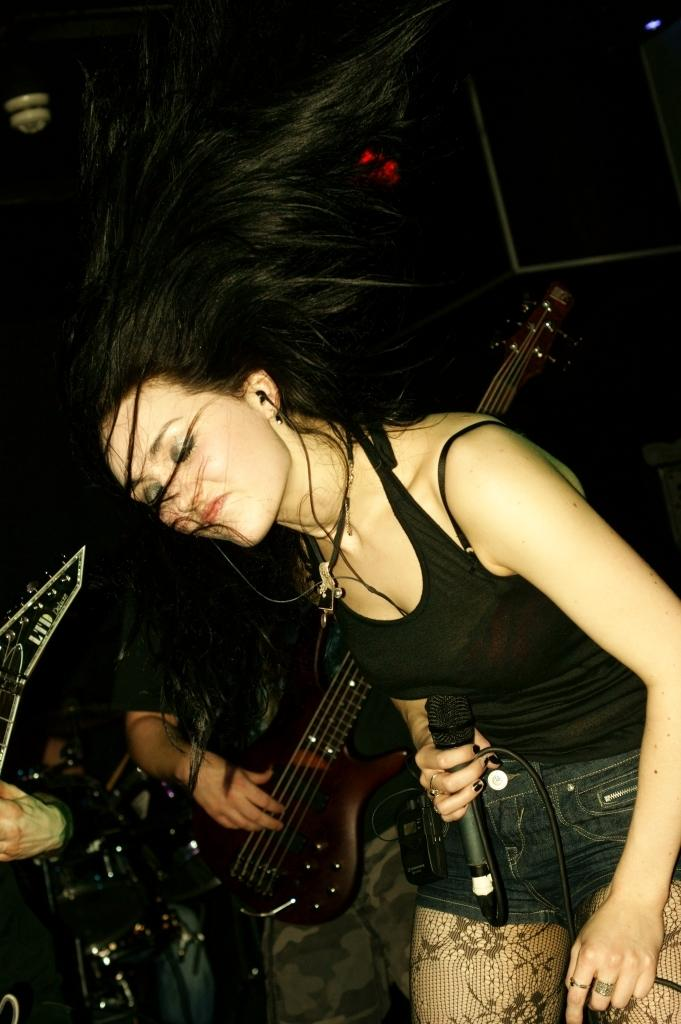What is the woman in the image wearing? The woman is wearing a black t-shirt. What is the woman holding in her hand? The woman is holding a microphone in her hand. What is the man in the image wearing? The man is wearing a black t-shirt. What is the man holding in his hands? The man is holding a guitar in his hands. What is the man doing with the guitar? The man is playing the guitar. What type of health insurance does the woman have in the image? There is no information about health insurance in the image; it focuses on the woman and the man with their respective clothing and objects. 